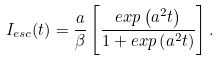Convert formula to latex. <formula><loc_0><loc_0><loc_500><loc_500>I _ { e s c } ( t ) = \frac { a } { \beta } \left [ \frac { e x p \left ( a ^ { 2 } t \right ) } { 1 + e x p \left ( a ^ { 2 } t \right ) } \right ] .</formula> 